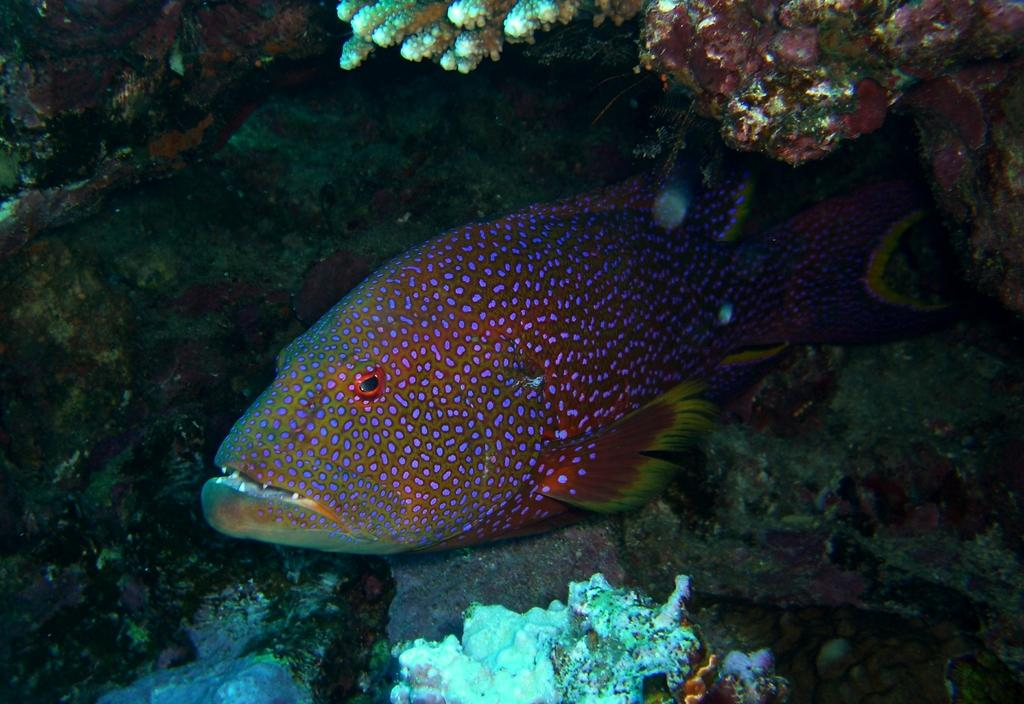What is the main subject of the image? The main subject of the image is a fish. What is the fish doing in the image? The fish is swimming in the water. What type of discussion is taking place in the image? There is no discussion present in the image; it features a fish swimming in the water. Can you tell me where the fish was purchased from in the image? There is no indication of where the fish was purchased from in the image; it simply shows the fish swimming in the water. 